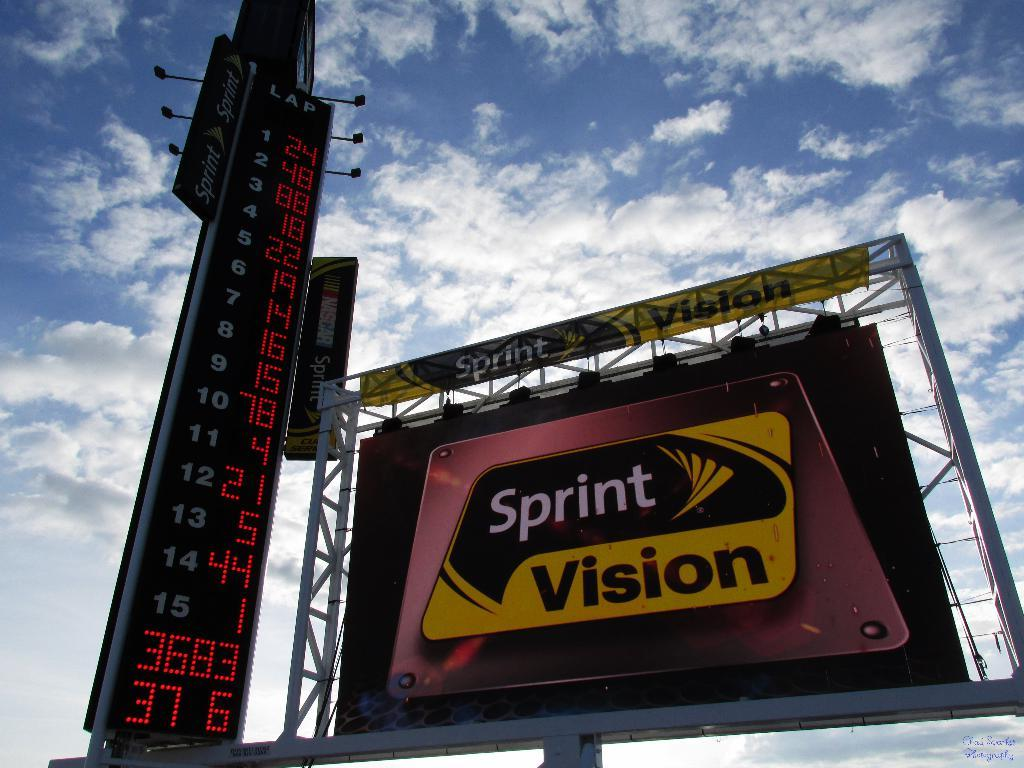Provide a one-sentence caption for the provided image. a big bill board for Sprint Vision is next to a Lap counter. 